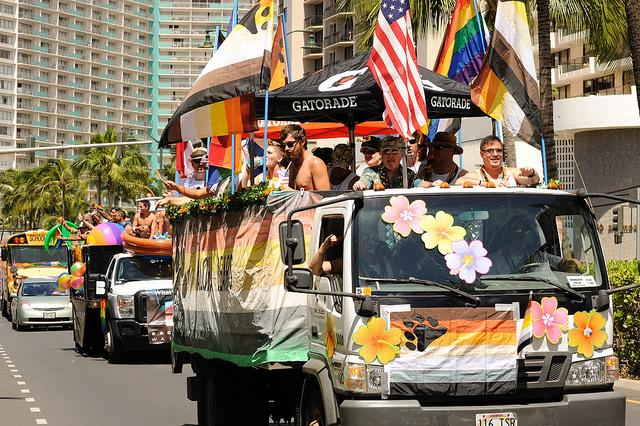Which company manufactures this beverage? Please explain your reasoning. pepsico. The umbrella has the name and logo for gatorade. this drink is similar to powerade and is made by coca-cola's main competitor. 